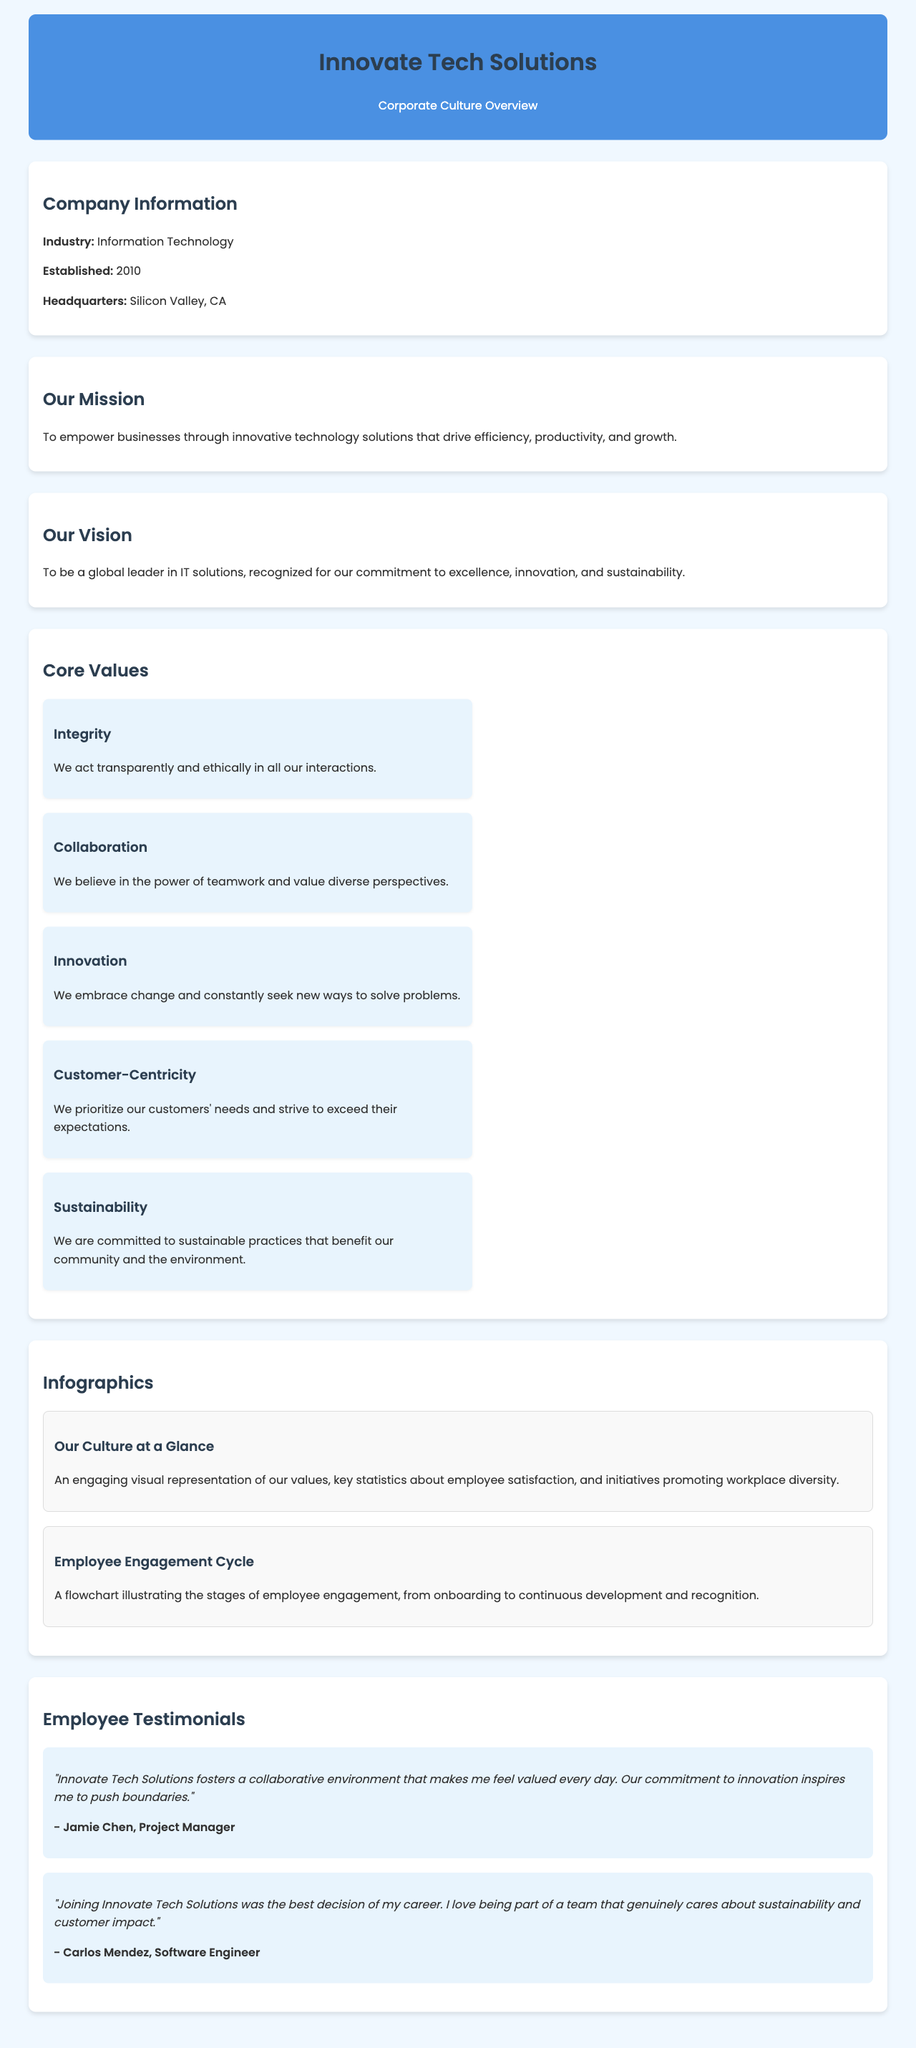What industry does Innovate Tech Solutions operate in? The document specifies the industry under "Company Information."
Answer: Information Technology When was Innovate Tech Solutions established? The establishment date is provided in the "Company Information" section.
Answer: 2010 Where is the headquarters of Innovate Tech Solutions located? The location of the headquarters is mentioned in the "Company Information" section.
Answer: Silicon Valley, CA What is the mission of Innovate Tech Solutions? The mission is clearly stated in the "Our Mission" section.
Answer: To empower businesses through innovative technology solutions that drive efficiency, productivity, and growth Which core value emphasizes teamwork and diverse perspectives? The core value promoting teamwork is listed among the core values.
Answer: Collaboration How many core values are outlined in the document? The number of core values can be counted in the "Core Values" section.
Answer: Five What type of visual representation is described in the infographics section? The infographics showcase key statistics and initiatives related to company culture.
Answer: Engaging visual representation Who is a testimonial from a Project Manager? The document includes a testimonial under "Employee Testimonials."
Answer: Jamie Chen What does Carlos Mendez appreciate about Innovate Tech Solutions? Carlos Mendez's testimonial reflects his views on the company culture.
Answer: Sustainability and customer impact 